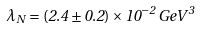<formula> <loc_0><loc_0><loc_500><loc_500>\lambda _ { N } = ( 2 . 4 \pm 0 . 2 ) \times 1 0 ^ { - 2 } \, G e V ^ { 3 }</formula> 